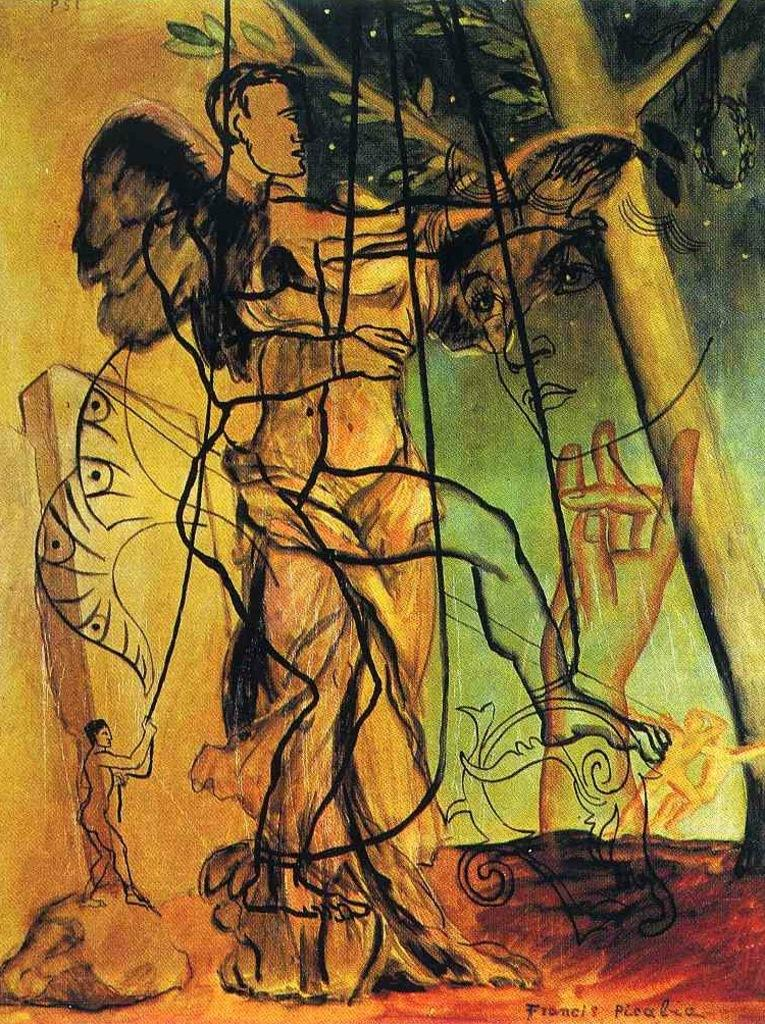What is featured in the image? There are paintings in the image. What subjects are depicted in the paintings? The paintings depict human beings and other objects. Where is the advertisement for the jar of beans located in the image? There is no advertisement or jar of beans present in the image. What type of beam is supporting the paintings in the image? There is no beam visible in the image; it only features paintings of human beings and other objects. 